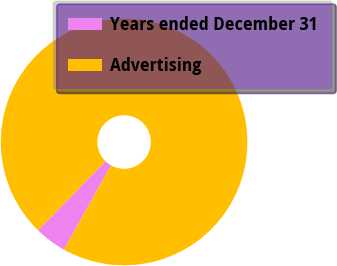Convert chart to OTSL. <chart><loc_0><loc_0><loc_500><loc_500><pie_chart><fcel>Years ended December 31<fcel>Advertising<nl><fcel>4.18%<fcel>95.82%<nl></chart> 